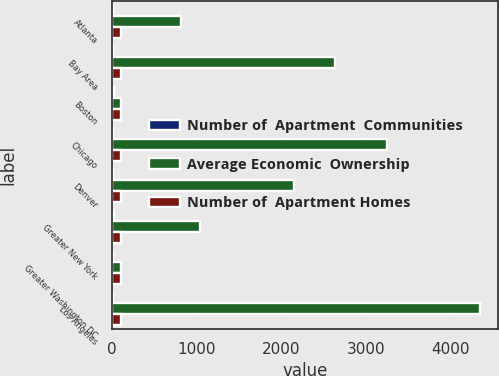Convert chart. <chart><loc_0><loc_0><loc_500><loc_500><stacked_bar_chart><ecel><fcel>Atlanta<fcel>Bay Area<fcel>Boston<fcel>Chicago<fcel>Denver<fcel>Greater New York<fcel>Greater Washington DC<fcel>Los Angeles<nl><fcel>Number of  Apartment  Communities<fcel>5<fcel>12<fcel>15<fcel>10<fcel>8<fcel>18<fcel>14<fcel>13<nl><fcel>Average Economic  Ownership<fcel>817<fcel>2632<fcel>100<fcel>3246<fcel>2151<fcel>1040<fcel>100<fcel>4347<nl><fcel>Number of  Apartment Homes<fcel>100<fcel>100<fcel>100<fcel>100<fcel>98<fcel>100<fcel>100<fcel>100<nl></chart> 